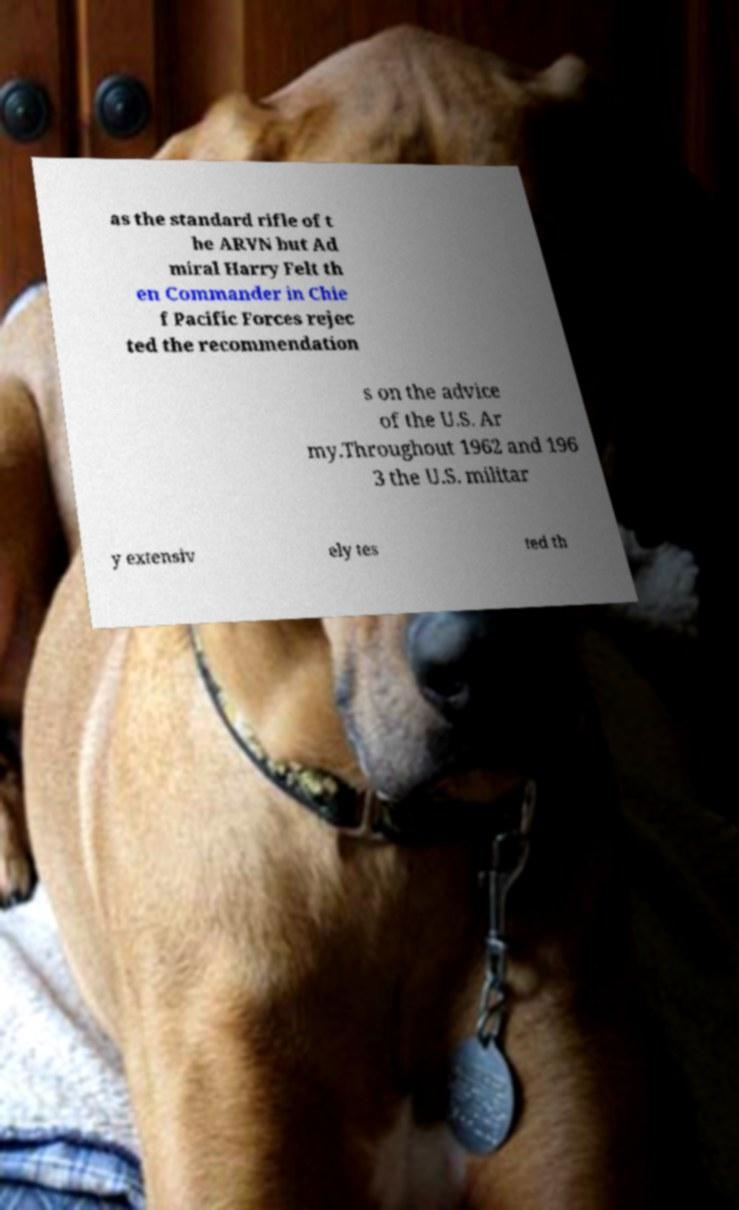Could you assist in decoding the text presented in this image and type it out clearly? as the standard rifle of t he ARVN but Ad miral Harry Felt th en Commander in Chie f Pacific Forces rejec ted the recommendation s on the advice of the U.S. Ar my.Throughout 1962 and 196 3 the U.S. militar y extensiv ely tes ted th 